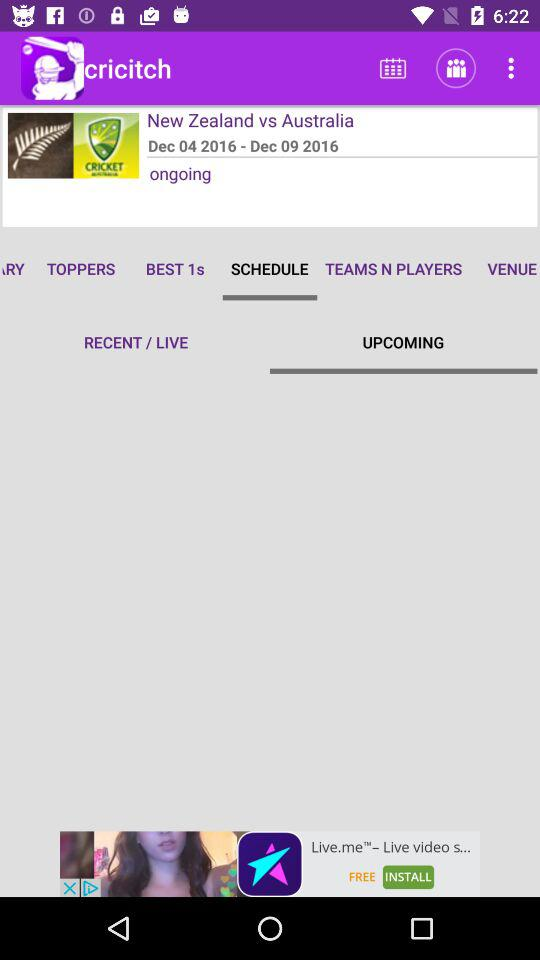What is the name of the application? The application name is "cricitch". 